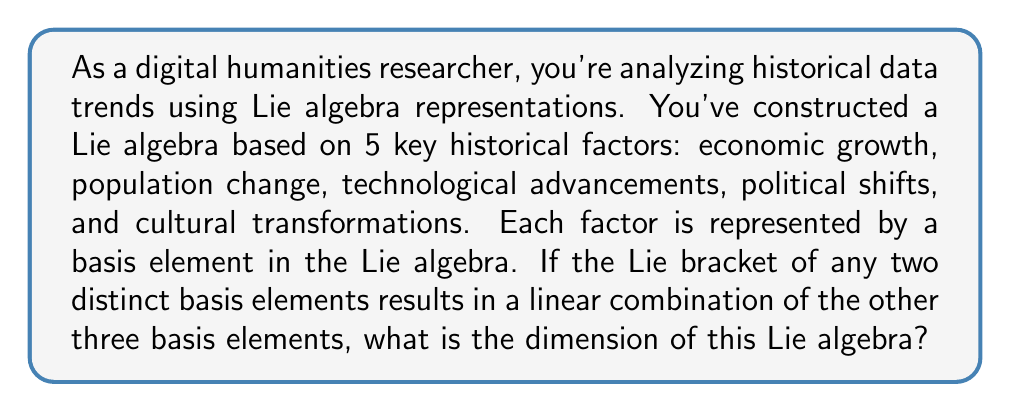Can you answer this question? To determine the dimension of this Lie algebra, we need to understand the structure of the algebra based on the given information:

1. We start with 5 basis elements, each representing a historical factor:
   Let's denote them as $e_1, e_2, e_3, e_4, e_5$

2. The Lie bracket operation is defined for any two distinct basis elements:
   $[e_i, e_j] = \sum_{k \neq i,j} a_k e_k$, where $a_k$ are some scalars

3. To determine the dimension, we need to check if these 5 basis elements are linearly independent or if there are any dependencies.

4. Given the information about the Lie bracket, we can see that no new elements are generated outside of the original 5 basis elements. This means the algebra is closed under the Lie bracket operation.

5. Moreover, the Lie bracket of any two elements doesn't produce either of those elements, only a combination of the other three. This indicates that there are no non-trivial linear dependencies among these basis elements.

6. In Lie algebra theory, the dimension of a Lie algebra is equal to the number of linearly independent basis elements.

7. Since all 5 basis elements are linearly independent and no additional elements are generated, the dimension of this Lie algebra is 5.

This 5-dimensional Lie algebra could be useful in digital humanities for analyzing complex interactions between different historical factors, where each factor influences the others in non-trivial ways.
Answer: The dimension of the Lie algebra is 5. 